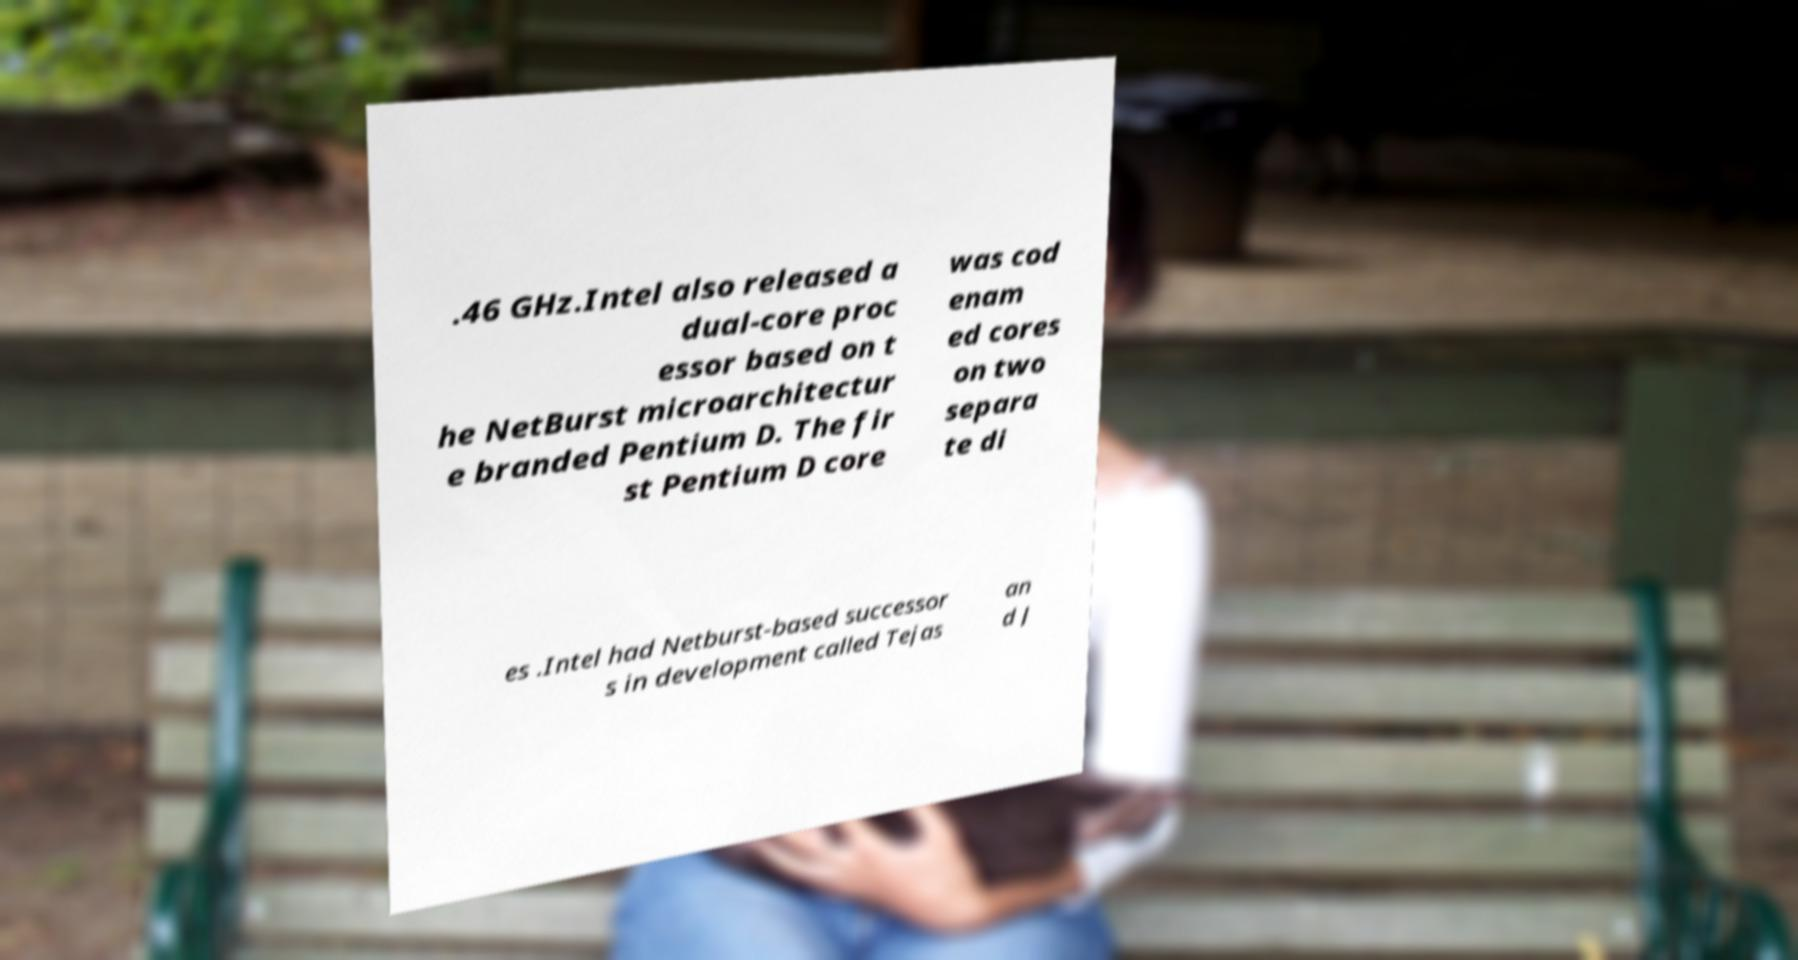What messages or text are displayed in this image? I need them in a readable, typed format. .46 GHz.Intel also released a dual-core proc essor based on t he NetBurst microarchitectur e branded Pentium D. The fir st Pentium D core was cod enam ed cores on two separa te di es .Intel had Netburst-based successor s in development called Tejas an d J 